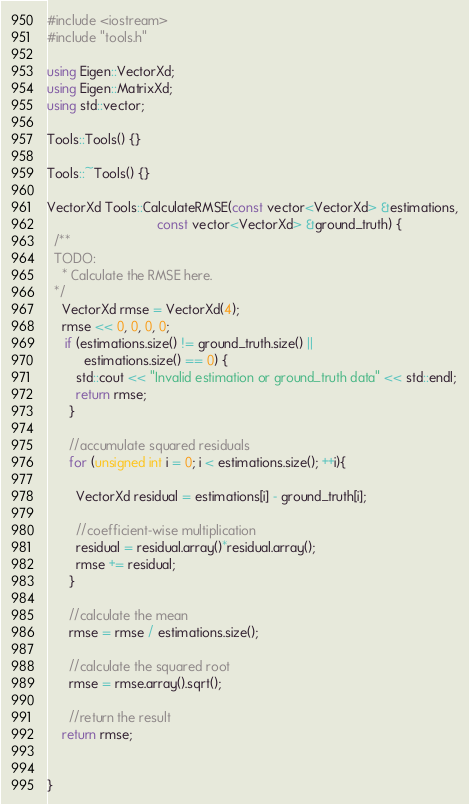<code> <loc_0><loc_0><loc_500><loc_500><_C++_>#include <iostream>
#include "tools.h"

using Eigen::VectorXd;
using Eigen::MatrixXd;
using std::vector;

Tools::Tools() {}

Tools::~Tools() {}

VectorXd Tools::CalculateRMSE(const vector<VectorXd> &estimations,
                              const vector<VectorXd> &ground_truth) {
  /**
  TODO:
    * Calculate the RMSE here.
  */
	VectorXd rmse = VectorXd(4);
	rmse << 0, 0, 0, 0;
	 if (estimations.size() != ground_truth.size() || 
	      estimations.size() == 0) {
	    std::cout << "Invalid estimation or ground_truth data" << std::endl;
	    return rmse;
	  }

	  //accumulate squared residuals
	  for (unsigned int i = 0; i < estimations.size(); ++i){

	    VectorXd residual = estimations[i] - ground_truth[i];

	    //coefficient-wise multiplication
	    residual = residual.array()*residual.array();
	    rmse += residual;
	  }

	  //calculate the mean
	  rmse = rmse / estimations.size();

	  //calculate the squared root
	  rmse = rmse.array().sqrt();

	  //return the result
	return rmse;


}</code> 